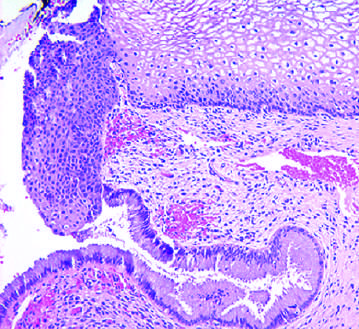did ervical transformation zone show the transition from mature glycogenated squamous epithelium, to immature metaplastic squamous cells, to columnar endocervical glandular epithelium?
Answer the question using a single word or phrase. Yes 